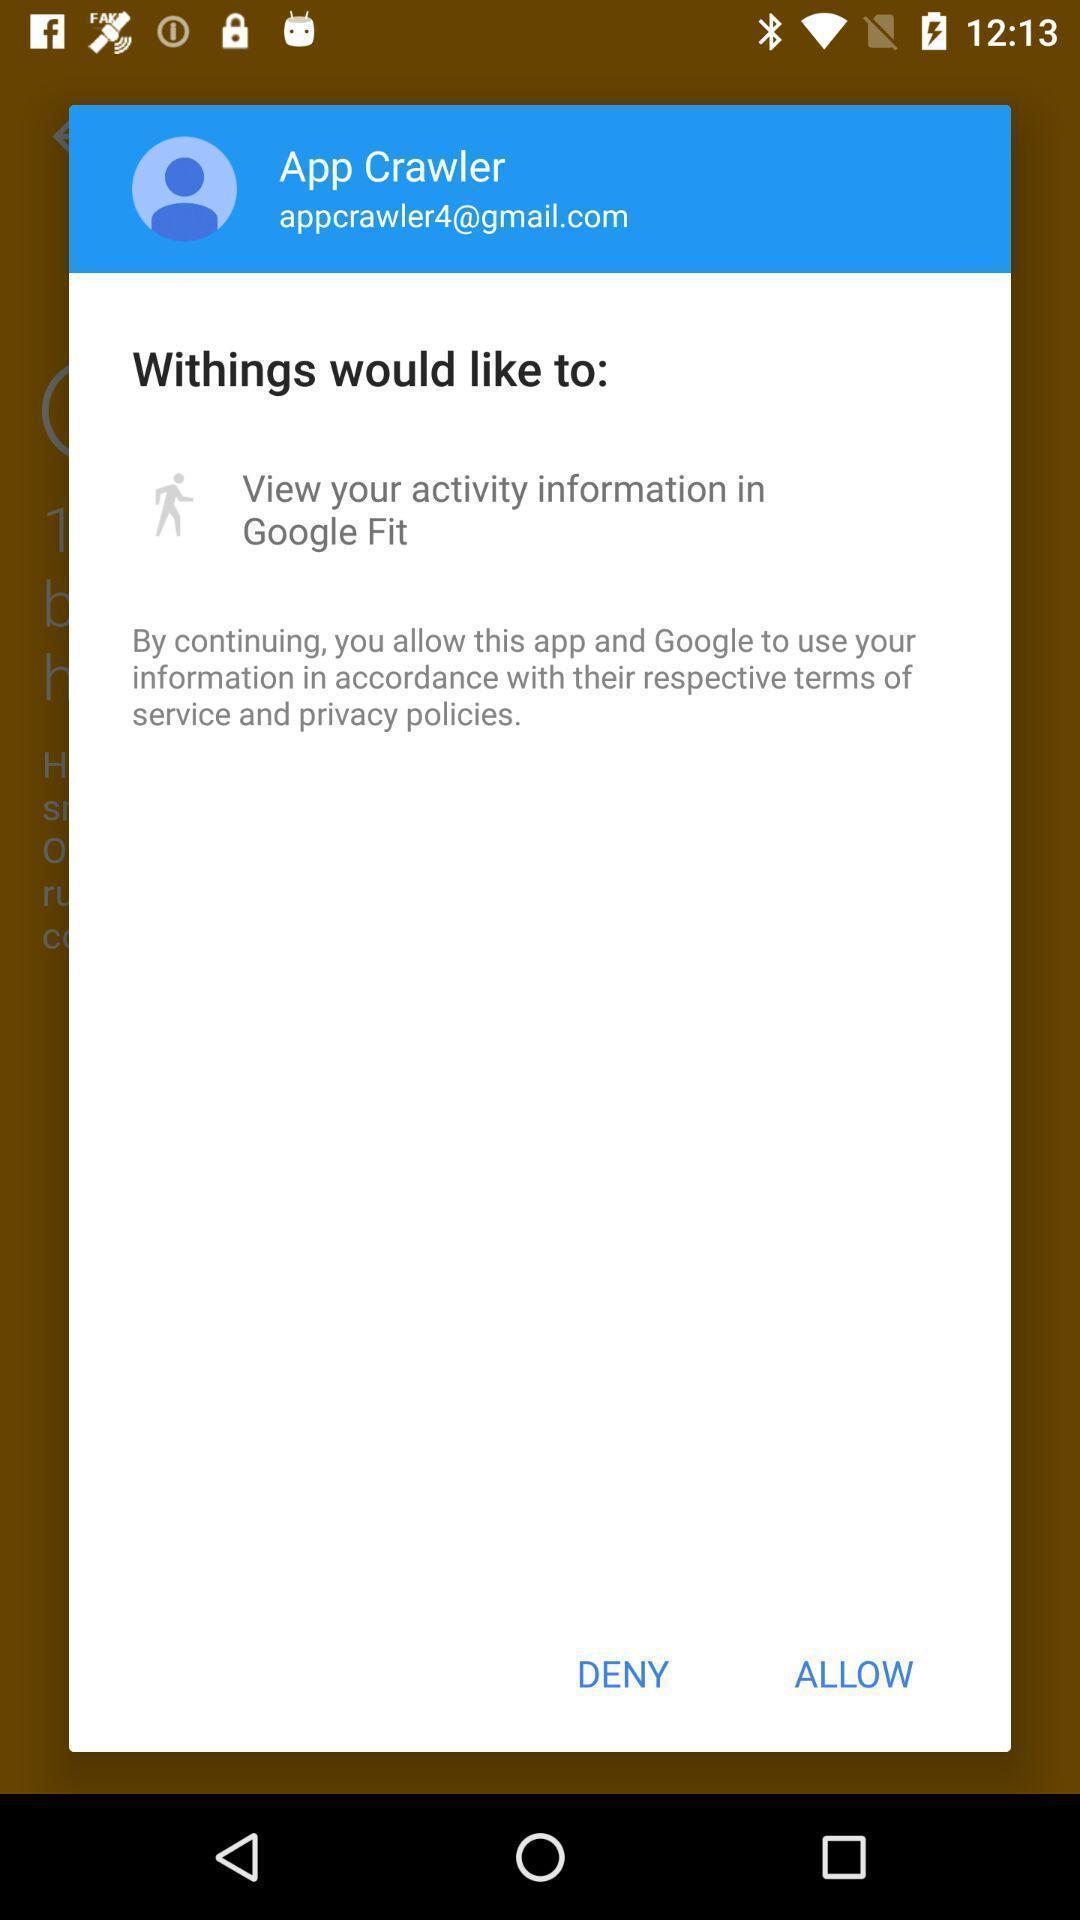Give me a narrative description of this picture. Popup of page with acceptance option in fitness application. 